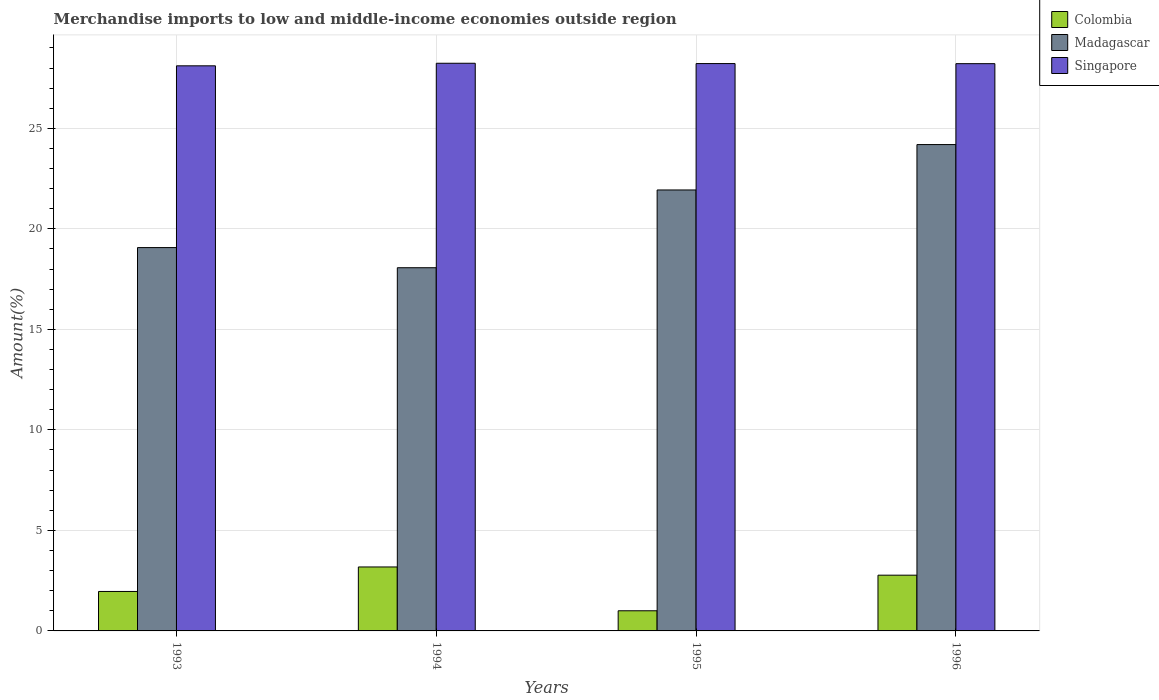How many different coloured bars are there?
Provide a short and direct response. 3. How many groups of bars are there?
Your response must be concise. 4. Are the number of bars on each tick of the X-axis equal?
Ensure brevity in your answer.  Yes. How many bars are there on the 4th tick from the left?
Give a very brief answer. 3. How many bars are there on the 2nd tick from the right?
Provide a succinct answer. 3. What is the label of the 3rd group of bars from the left?
Provide a short and direct response. 1995. What is the percentage of amount earned from merchandise imports in Singapore in 1995?
Offer a terse response. 28.22. Across all years, what is the maximum percentage of amount earned from merchandise imports in Madagascar?
Offer a very short reply. 24.19. Across all years, what is the minimum percentage of amount earned from merchandise imports in Madagascar?
Provide a succinct answer. 18.07. What is the total percentage of amount earned from merchandise imports in Colombia in the graph?
Ensure brevity in your answer.  8.92. What is the difference between the percentage of amount earned from merchandise imports in Madagascar in 1993 and that in 1994?
Your answer should be compact. 1. What is the difference between the percentage of amount earned from merchandise imports in Madagascar in 1993 and the percentage of amount earned from merchandise imports in Singapore in 1995?
Give a very brief answer. -9.15. What is the average percentage of amount earned from merchandise imports in Singapore per year?
Make the answer very short. 28.2. In the year 1994, what is the difference between the percentage of amount earned from merchandise imports in Singapore and percentage of amount earned from merchandise imports in Colombia?
Provide a short and direct response. 25.05. In how many years, is the percentage of amount earned from merchandise imports in Madagascar greater than 11 %?
Offer a terse response. 4. What is the ratio of the percentage of amount earned from merchandise imports in Singapore in 1995 to that in 1996?
Your answer should be compact. 1. Is the percentage of amount earned from merchandise imports in Madagascar in 1995 less than that in 1996?
Your response must be concise. Yes. Is the difference between the percentage of amount earned from merchandise imports in Singapore in 1994 and 1996 greater than the difference between the percentage of amount earned from merchandise imports in Colombia in 1994 and 1996?
Offer a very short reply. No. What is the difference between the highest and the second highest percentage of amount earned from merchandise imports in Singapore?
Make the answer very short. 0.02. What is the difference between the highest and the lowest percentage of amount earned from merchandise imports in Madagascar?
Your response must be concise. 6.13. In how many years, is the percentage of amount earned from merchandise imports in Singapore greater than the average percentage of amount earned from merchandise imports in Singapore taken over all years?
Make the answer very short. 3. Is the sum of the percentage of amount earned from merchandise imports in Singapore in 1993 and 1995 greater than the maximum percentage of amount earned from merchandise imports in Madagascar across all years?
Your answer should be very brief. Yes. What does the 3rd bar from the left in 1993 represents?
Ensure brevity in your answer.  Singapore. What does the 1st bar from the right in 1994 represents?
Your answer should be compact. Singapore. Are all the bars in the graph horizontal?
Your answer should be very brief. No. What is the difference between two consecutive major ticks on the Y-axis?
Offer a terse response. 5. Does the graph contain any zero values?
Provide a short and direct response. No. Where does the legend appear in the graph?
Make the answer very short. Top right. How are the legend labels stacked?
Give a very brief answer. Vertical. What is the title of the graph?
Ensure brevity in your answer.  Merchandise imports to low and middle-income economies outside region. What is the label or title of the Y-axis?
Keep it short and to the point. Amount(%). What is the Amount(%) of Colombia in 1993?
Your answer should be very brief. 1.96. What is the Amount(%) in Madagascar in 1993?
Offer a terse response. 19.07. What is the Amount(%) in Singapore in 1993?
Make the answer very short. 28.11. What is the Amount(%) of Colombia in 1994?
Make the answer very short. 3.18. What is the Amount(%) in Madagascar in 1994?
Provide a short and direct response. 18.07. What is the Amount(%) in Singapore in 1994?
Your answer should be very brief. 28.24. What is the Amount(%) in Colombia in 1995?
Ensure brevity in your answer.  1. What is the Amount(%) in Madagascar in 1995?
Ensure brevity in your answer.  21.93. What is the Amount(%) of Singapore in 1995?
Keep it short and to the point. 28.22. What is the Amount(%) of Colombia in 1996?
Offer a very short reply. 2.77. What is the Amount(%) in Madagascar in 1996?
Provide a succinct answer. 24.19. What is the Amount(%) of Singapore in 1996?
Your answer should be very brief. 28.22. Across all years, what is the maximum Amount(%) in Colombia?
Provide a short and direct response. 3.18. Across all years, what is the maximum Amount(%) of Madagascar?
Your response must be concise. 24.19. Across all years, what is the maximum Amount(%) in Singapore?
Provide a short and direct response. 28.24. Across all years, what is the minimum Amount(%) of Colombia?
Provide a short and direct response. 1. Across all years, what is the minimum Amount(%) in Madagascar?
Offer a terse response. 18.07. Across all years, what is the minimum Amount(%) in Singapore?
Your response must be concise. 28.11. What is the total Amount(%) in Colombia in the graph?
Give a very brief answer. 8.92. What is the total Amount(%) of Madagascar in the graph?
Make the answer very short. 83.26. What is the total Amount(%) in Singapore in the graph?
Provide a short and direct response. 112.78. What is the difference between the Amount(%) in Colombia in 1993 and that in 1994?
Provide a short and direct response. -1.22. What is the difference between the Amount(%) of Singapore in 1993 and that in 1994?
Offer a terse response. -0.13. What is the difference between the Amount(%) in Colombia in 1993 and that in 1995?
Provide a short and direct response. 0.96. What is the difference between the Amount(%) of Madagascar in 1993 and that in 1995?
Make the answer very short. -2.87. What is the difference between the Amount(%) of Singapore in 1993 and that in 1995?
Offer a terse response. -0.11. What is the difference between the Amount(%) in Colombia in 1993 and that in 1996?
Offer a very short reply. -0.81. What is the difference between the Amount(%) of Madagascar in 1993 and that in 1996?
Keep it short and to the point. -5.12. What is the difference between the Amount(%) of Singapore in 1993 and that in 1996?
Your answer should be very brief. -0.11. What is the difference between the Amount(%) of Colombia in 1994 and that in 1995?
Provide a short and direct response. 2.18. What is the difference between the Amount(%) of Madagascar in 1994 and that in 1995?
Offer a very short reply. -3.87. What is the difference between the Amount(%) of Singapore in 1994 and that in 1995?
Give a very brief answer. 0.02. What is the difference between the Amount(%) of Colombia in 1994 and that in 1996?
Keep it short and to the point. 0.41. What is the difference between the Amount(%) in Madagascar in 1994 and that in 1996?
Your answer should be compact. -6.13. What is the difference between the Amount(%) of Singapore in 1994 and that in 1996?
Make the answer very short. 0.02. What is the difference between the Amount(%) of Colombia in 1995 and that in 1996?
Keep it short and to the point. -1.77. What is the difference between the Amount(%) of Madagascar in 1995 and that in 1996?
Your answer should be compact. -2.26. What is the difference between the Amount(%) in Singapore in 1995 and that in 1996?
Provide a succinct answer. 0. What is the difference between the Amount(%) in Colombia in 1993 and the Amount(%) in Madagascar in 1994?
Offer a very short reply. -16.1. What is the difference between the Amount(%) in Colombia in 1993 and the Amount(%) in Singapore in 1994?
Your answer should be very brief. -26.27. What is the difference between the Amount(%) in Madagascar in 1993 and the Amount(%) in Singapore in 1994?
Keep it short and to the point. -9.17. What is the difference between the Amount(%) in Colombia in 1993 and the Amount(%) in Madagascar in 1995?
Your answer should be compact. -19.97. What is the difference between the Amount(%) of Colombia in 1993 and the Amount(%) of Singapore in 1995?
Offer a terse response. -26.26. What is the difference between the Amount(%) of Madagascar in 1993 and the Amount(%) of Singapore in 1995?
Provide a succinct answer. -9.15. What is the difference between the Amount(%) of Colombia in 1993 and the Amount(%) of Madagascar in 1996?
Provide a succinct answer. -22.23. What is the difference between the Amount(%) in Colombia in 1993 and the Amount(%) in Singapore in 1996?
Offer a terse response. -26.25. What is the difference between the Amount(%) in Madagascar in 1993 and the Amount(%) in Singapore in 1996?
Provide a succinct answer. -9.15. What is the difference between the Amount(%) of Colombia in 1994 and the Amount(%) of Madagascar in 1995?
Give a very brief answer. -18.75. What is the difference between the Amount(%) in Colombia in 1994 and the Amount(%) in Singapore in 1995?
Ensure brevity in your answer.  -25.04. What is the difference between the Amount(%) of Madagascar in 1994 and the Amount(%) of Singapore in 1995?
Ensure brevity in your answer.  -10.15. What is the difference between the Amount(%) of Colombia in 1994 and the Amount(%) of Madagascar in 1996?
Your answer should be compact. -21.01. What is the difference between the Amount(%) in Colombia in 1994 and the Amount(%) in Singapore in 1996?
Provide a short and direct response. -25.03. What is the difference between the Amount(%) in Madagascar in 1994 and the Amount(%) in Singapore in 1996?
Your answer should be compact. -10.15. What is the difference between the Amount(%) in Colombia in 1995 and the Amount(%) in Madagascar in 1996?
Your answer should be compact. -23.19. What is the difference between the Amount(%) in Colombia in 1995 and the Amount(%) in Singapore in 1996?
Keep it short and to the point. -27.21. What is the difference between the Amount(%) in Madagascar in 1995 and the Amount(%) in Singapore in 1996?
Provide a succinct answer. -6.28. What is the average Amount(%) in Colombia per year?
Ensure brevity in your answer.  2.23. What is the average Amount(%) of Madagascar per year?
Provide a succinct answer. 20.81. What is the average Amount(%) in Singapore per year?
Provide a succinct answer. 28.2. In the year 1993, what is the difference between the Amount(%) of Colombia and Amount(%) of Madagascar?
Provide a succinct answer. -17.1. In the year 1993, what is the difference between the Amount(%) in Colombia and Amount(%) in Singapore?
Ensure brevity in your answer.  -26.15. In the year 1993, what is the difference between the Amount(%) of Madagascar and Amount(%) of Singapore?
Your response must be concise. -9.04. In the year 1994, what is the difference between the Amount(%) of Colombia and Amount(%) of Madagascar?
Offer a very short reply. -14.88. In the year 1994, what is the difference between the Amount(%) of Colombia and Amount(%) of Singapore?
Ensure brevity in your answer.  -25.05. In the year 1994, what is the difference between the Amount(%) of Madagascar and Amount(%) of Singapore?
Keep it short and to the point. -10.17. In the year 1995, what is the difference between the Amount(%) of Colombia and Amount(%) of Madagascar?
Give a very brief answer. -20.93. In the year 1995, what is the difference between the Amount(%) of Colombia and Amount(%) of Singapore?
Make the answer very short. -27.22. In the year 1995, what is the difference between the Amount(%) of Madagascar and Amount(%) of Singapore?
Provide a succinct answer. -6.29. In the year 1996, what is the difference between the Amount(%) of Colombia and Amount(%) of Madagascar?
Your answer should be compact. -21.42. In the year 1996, what is the difference between the Amount(%) of Colombia and Amount(%) of Singapore?
Make the answer very short. -25.44. In the year 1996, what is the difference between the Amount(%) of Madagascar and Amount(%) of Singapore?
Provide a succinct answer. -4.02. What is the ratio of the Amount(%) in Colombia in 1993 to that in 1994?
Ensure brevity in your answer.  0.62. What is the ratio of the Amount(%) of Madagascar in 1993 to that in 1994?
Give a very brief answer. 1.06. What is the ratio of the Amount(%) in Singapore in 1993 to that in 1994?
Your response must be concise. 1. What is the ratio of the Amount(%) in Colombia in 1993 to that in 1995?
Make the answer very short. 1.96. What is the ratio of the Amount(%) of Madagascar in 1993 to that in 1995?
Ensure brevity in your answer.  0.87. What is the ratio of the Amount(%) in Singapore in 1993 to that in 1995?
Give a very brief answer. 1. What is the ratio of the Amount(%) of Colombia in 1993 to that in 1996?
Give a very brief answer. 0.71. What is the ratio of the Amount(%) in Madagascar in 1993 to that in 1996?
Give a very brief answer. 0.79. What is the ratio of the Amount(%) of Singapore in 1993 to that in 1996?
Make the answer very short. 1. What is the ratio of the Amount(%) of Colombia in 1994 to that in 1995?
Provide a short and direct response. 3.17. What is the ratio of the Amount(%) of Madagascar in 1994 to that in 1995?
Give a very brief answer. 0.82. What is the ratio of the Amount(%) of Colombia in 1994 to that in 1996?
Your answer should be very brief. 1.15. What is the ratio of the Amount(%) of Madagascar in 1994 to that in 1996?
Offer a terse response. 0.75. What is the ratio of the Amount(%) in Singapore in 1994 to that in 1996?
Keep it short and to the point. 1. What is the ratio of the Amount(%) in Colombia in 1995 to that in 1996?
Keep it short and to the point. 0.36. What is the ratio of the Amount(%) of Madagascar in 1995 to that in 1996?
Your answer should be compact. 0.91. What is the ratio of the Amount(%) in Singapore in 1995 to that in 1996?
Your answer should be compact. 1. What is the difference between the highest and the second highest Amount(%) of Colombia?
Offer a very short reply. 0.41. What is the difference between the highest and the second highest Amount(%) of Madagascar?
Give a very brief answer. 2.26. What is the difference between the highest and the second highest Amount(%) in Singapore?
Offer a very short reply. 0.02. What is the difference between the highest and the lowest Amount(%) of Colombia?
Ensure brevity in your answer.  2.18. What is the difference between the highest and the lowest Amount(%) of Madagascar?
Ensure brevity in your answer.  6.13. What is the difference between the highest and the lowest Amount(%) of Singapore?
Provide a succinct answer. 0.13. 